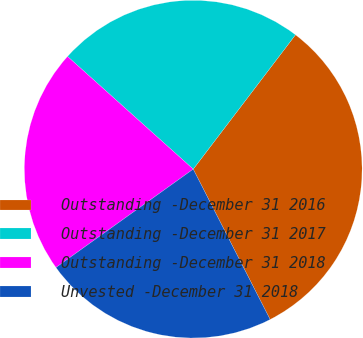Convert chart. <chart><loc_0><loc_0><loc_500><loc_500><pie_chart><fcel>Outstanding -December 31 2016<fcel>Outstanding -December 31 2017<fcel>Outstanding -December 31 2018<fcel>Unvested -December 31 2018<nl><fcel>32.12%<fcel>23.72%<fcel>21.53%<fcel>22.63%<nl></chart> 